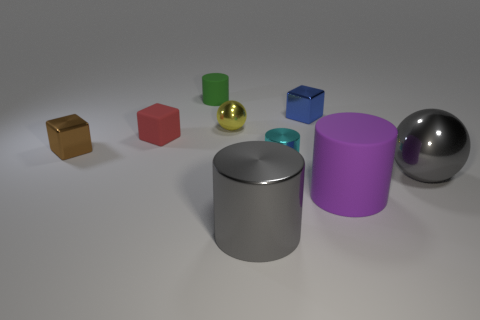There is a large object that is the same color as the big sphere; what is its shape?
Your response must be concise. Cylinder. There is a cylinder that is the same color as the large ball; what material is it?
Offer a very short reply. Metal. Does the metallic sphere in front of the small red block have the same color as the thing that is in front of the big purple rubber object?
Give a very brief answer. Yes. There is a big gray ball that is in front of the cyan metal thing; how many green matte cylinders are to the left of it?
Provide a succinct answer. 1. Is there a large red metallic cylinder?
Give a very brief answer. No. What number of other things are there of the same color as the small shiny cylinder?
Ensure brevity in your answer.  0. Is the number of blue cylinders less than the number of metal cylinders?
Provide a short and direct response. Yes. There is a large gray thing that is behind the matte thing in front of the cyan object; what is its shape?
Your answer should be compact. Sphere. There is a tiny cyan shiny thing; are there any things behind it?
Provide a short and direct response. Yes. The metal cylinder that is the same size as the yellow sphere is what color?
Make the answer very short. Cyan. 